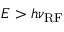<formula> <loc_0><loc_0><loc_500><loc_500>E > h \nu _ { R F }</formula> 